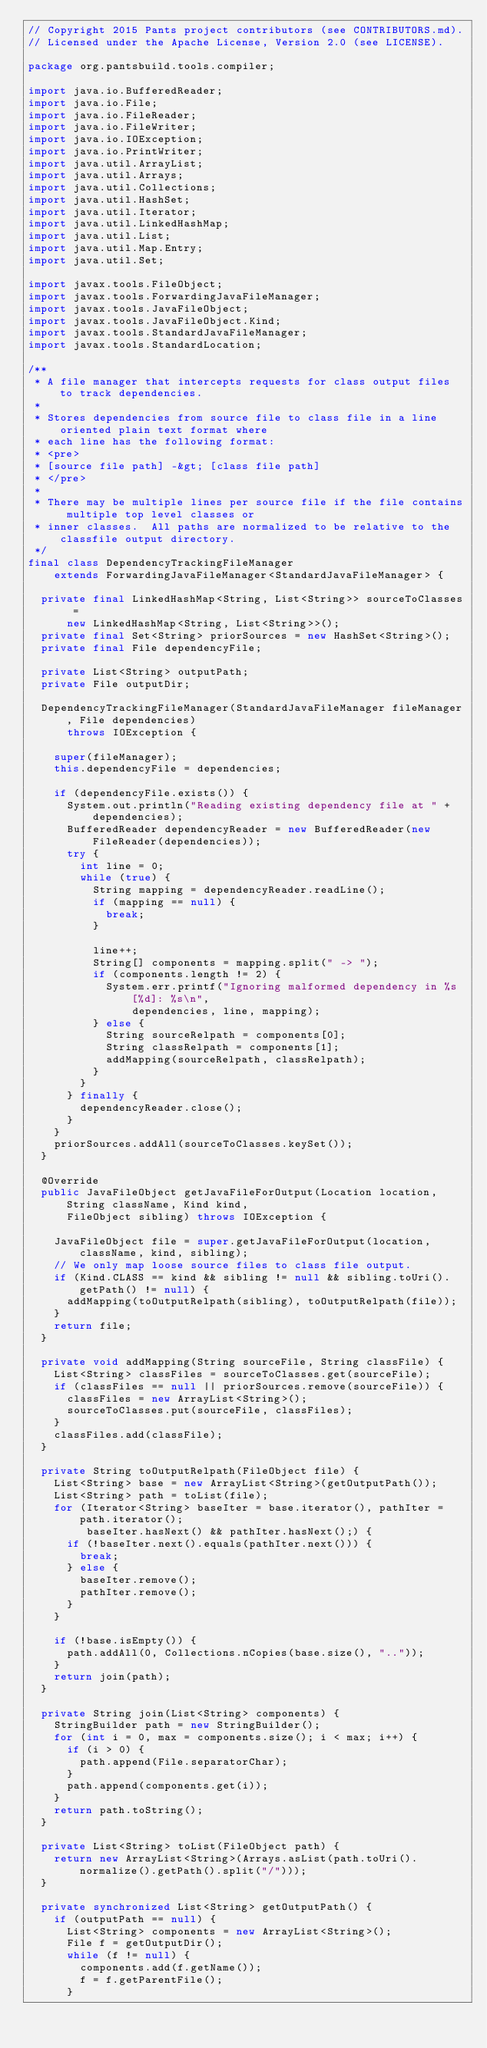<code> <loc_0><loc_0><loc_500><loc_500><_Java_>// Copyright 2015 Pants project contributors (see CONTRIBUTORS.md).
// Licensed under the Apache License, Version 2.0 (see LICENSE).

package org.pantsbuild.tools.compiler;

import java.io.BufferedReader;
import java.io.File;
import java.io.FileReader;
import java.io.FileWriter;
import java.io.IOException;
import java.io.PrintWriter;
import java.util.ArrayList;
import java.util.Arrays;
import java.util.Collections;
import java.util.HashSet;
import java.util.Iterator;
import java.util.LinkedHashMap;
import java.util.List;
import java.util.Map.Entry;
import java.util.Set;

import javax.tools.FileObject;
import javax.tools.ForwardingJavaFileManager;
import javax.tools.JavaFileObject;
import javax.tools.JavaFileObject.Kind;
import javax.tools.StandardJavaFileManager;
import javax.tools.StandardLocation;

/**
 * A file manager that intercepts requests for class output files to track dependencies.
 *
 * Stores dependencies from source file to class file in a line oriented plain text format where
 * each line has the following format:
 * <pre>
 * [source file path] -&gt; [class file path]
 * </pre>
 *
 * There may be multiple lines per source file if the file contains multiple top level classes or
 * inner classes.  All paths are normalized to be relative to the classfile output directory.
 */
final class DependencyTrackingFileManager
    extends ForwardingJavaFileManager<StandardJavaFileManager> {

  private final LinkedHashMap<String, List<String>> sourceToClasses =
      new LinkedHashMap<String, List<String>>();
  private final Set<String> priorSources = new HashSet<String>();
  private final File dependencyFile;

  private List<String> outputPath;
  private File outputDir;

  DependencyTrackingFileManager(StandardJavaFileManager fileManager, File dependencies)
      throws IOException {

    super(fileManager);
    this.dependencyFile = dependencies;

    if (dependencyFile.exists()) {
      System.out.println("Reading existing dependency file at " + dependencies);
      BufferedReader dependencyReader = new BufferedReader(new FileReader(dependencies));
      try {
        int line = 0;
        while (true) {
          String mapping = dependencyReader.readLine();
          if (mapping == null) {
            break;
          }

          line++;
          String[] components = mapping.split(" -> ");
          if (components.length != 2) {
            System.err.printf("Ignoring malformed dependency in %s[%d]: %s\n",
                dependencies, line, mapping);
          } else {
            String sourceRelpath = components[0];
            String classRelpath = components[1];
            addMapping(sourceRelpath, classRelpath);
          }
        }
      } finally {
        dependencyReader.close();
      }
    }
    priorSources.addAll(sourceToClasses.keySet());
  }

  @Override
  public JavaFileObject getJavaFileForOutput(Location location, String className, Kind kind,
      FileObject sibling) throws IOException {

    JavaFileObject file = super.getJavaFileForOutput(location, className, kind, sibling);
    // We only map loose source files to class file output.
    if (Kind.CLASS == kind && sibling != null && sibling.toUri().getPath() != null) {
      addMapping(toOutputRelpath(sibling), toOutputRelpath(file));
    }
    return file;
  }

  private void addMapping(String sourceFile, String classFile) {
    List<String> classFiles = sourceToClasses.get(sourceFile);
    if (classFiles == null || priorSources.remove(sourceFile)) {
      classFiles = new ArrayList<String>();
      sourceToClasses.put(sourceFile, classFiles);
    }
    classFiles.add(classFile);
  }

  private String toOutputRelpath(FileObject file) {
    List<String> base = new ArrayList<String>(getOutputPath());
    List<String> path = toList(file);
    for (Iterator<String> baseIter = base.iterator(), pathIter = path.iterator();
         baseIter.hasNext() && pathIter.hasNext();) {
      if (!baseIter.next().equals(pathIter.next())) {
        break;
      } else {
        baseIter.remove();
        pathIter.remove();
      }
    }

    if (!base.isEmpty()) {
      path.addAll(0, Collections.nCopies(base.size(), ".."));
    }
    return join(path);
  }

  private String join(List<String> components) {
    StringBuilder path = new StringBuilder();
    for (int i = 0, max = components.size(); i < max; i++) {
      if (i > 0) {
        path.append(File.separatorChar);
      }
      path.append(components.get(i));
    }
    return path.toString();
  }

  private List<String> toList(FileObject path) {
    return new ArrayList<String>(Arrays.asList(path.toUri().normalize().getPath().split("/")));
  }

  private synchronized List<String> getOutputPath() {
    if (outputPath == null) {
      List<String> components = new ArrayList<String>();
      File f = getOutputDir();
      while (f != null) {
        components.add(f.getName());
        f = f.getParentFile();
      }</code> 